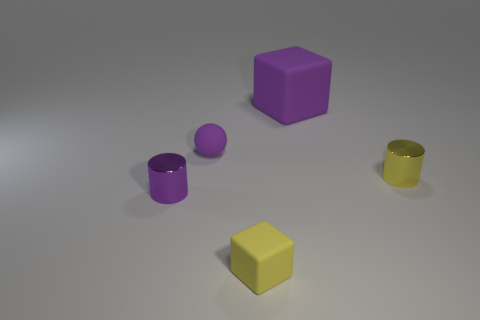Can you tell me the colors of the different objects and how many items are of each color? Certainly! In the image, there are two purple objects, a cube and a cylinder, and two yellow items, a cube and another smaller cylinder. 